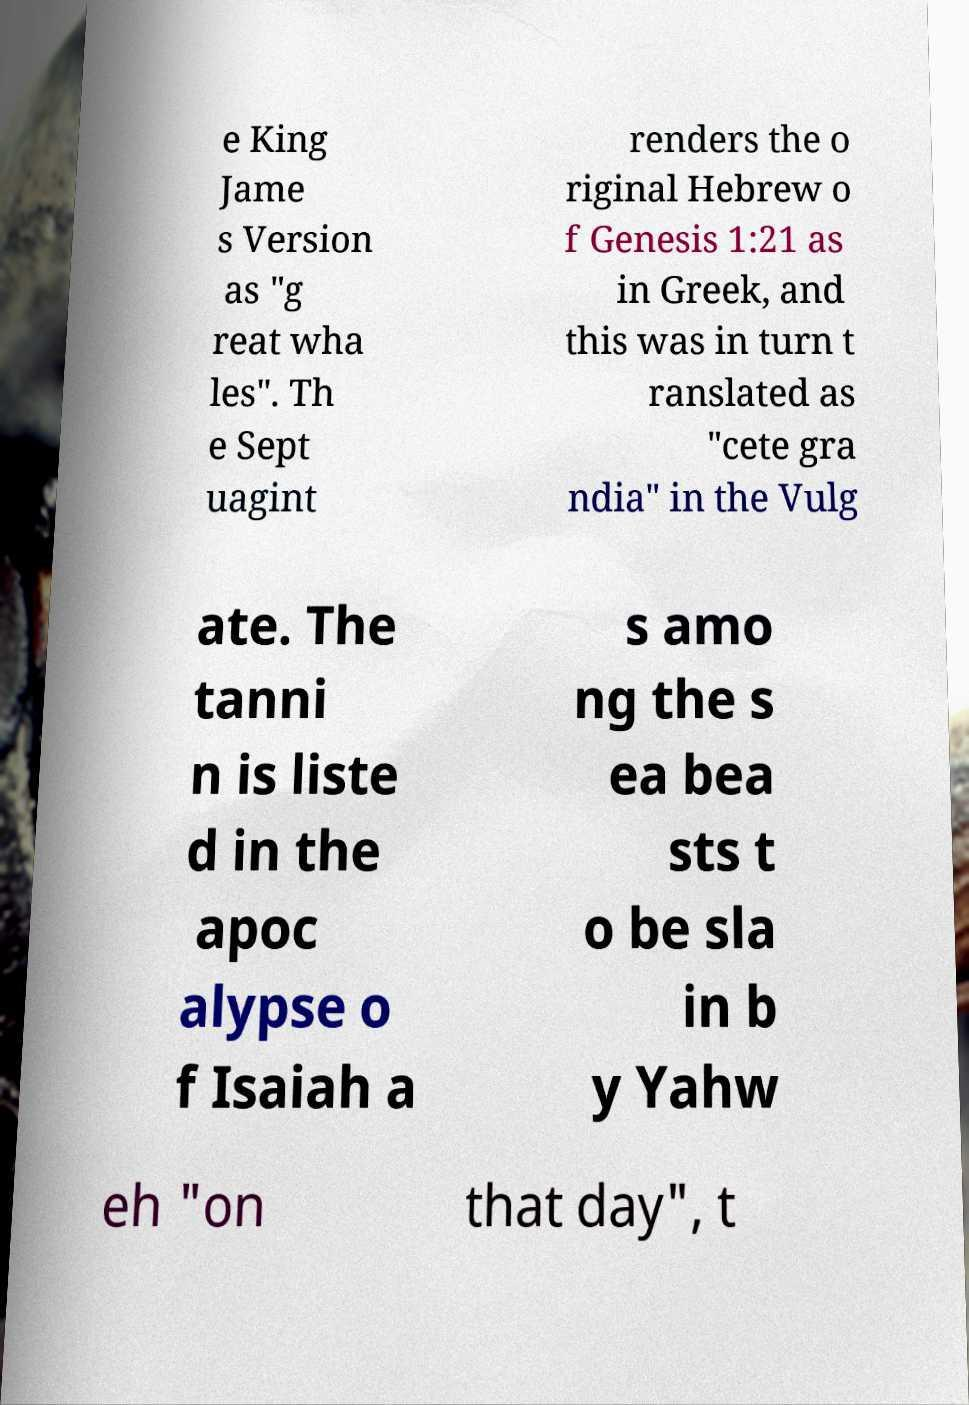Please identify and transcribe the text found in this image. e King Jame s Version as "g reat wha les". Th e Sept uagint renders the o riginal Hebrew o f Genesis 1:21 as in Greek, and this was in turn t ranslated as "cete gra ndia" in the Vulg ate. The tanni n is liste d in the apoc alypse o f Isaiah a s amo ng the s ea bea sts t o be sla in b y Yahw eh "on that day", t 